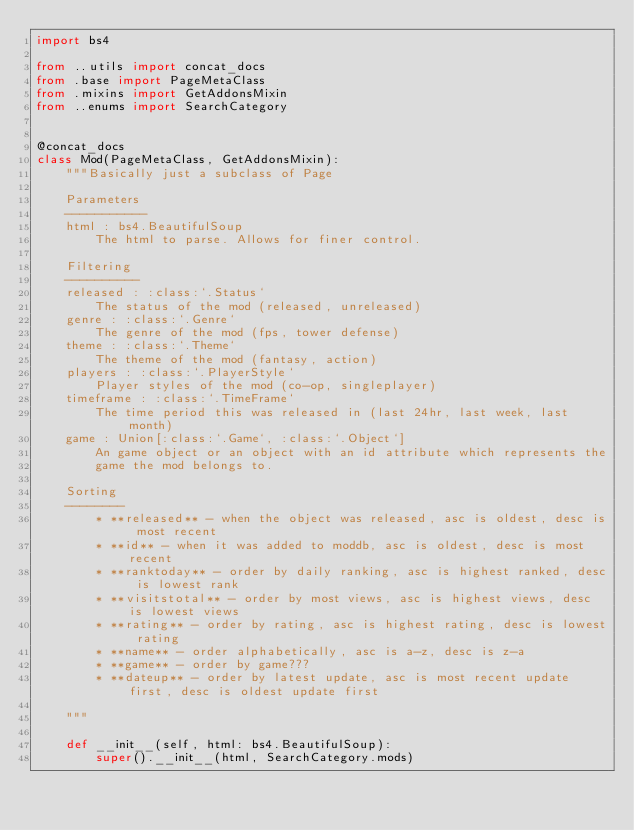<code> <loc_0><loc_0><loc_500><loc_500><_Python_>import bs4

from ..utils import concat_docs
from .base import PageMetaClass
from .mixins import GetAddonsMixin
from ..enums import SearchCategory


@concat_docs
class Mod(PageMetaClass, GetAddonsMixin):
    """Basically just a subclass of Page

    Parameters
    -----------
    html : bs4.BeautifulSoup
        The html to parse. Allows for finer control.

    Filtering
    ----------
    released : :class:`.Status`
        The status of the mod (released, unreleased)
    genre : :class:`.Genre`
        The genre of the mod (fps, tower defense)
    theme : :class:`.Theme`
        The theme of the mod (fantasy, action)
    players : :class:`.PlayerStyle`
        Player styles of the mod (co-op, singleplayer)
    timeframe : :class:`.TimeFrame`
        The time period this was released in (last 24hr, last week, last month)
    game : Union[:class:`.Game`, :class:`.Object`]
        An game object or an object with an id attribute which represents the
        game the mod belongs to.

    Sorting
    --------
        * **released** - when the object was released, asc is oldest, desc is most recent
        * **id** - when it was added to moddb, asc is oldest, desc is most recent
        * **ranktoday** - order by daily ranking, asc is highest ranked, desc is lowest rank
        * **visitstotal** - order by most views, asc is highest views, desc is lowest views
        * **rating** - order by rating, asc is highest rating, desc is lowest rating
        * **name** - order alphabetically, asc is a-z, desc is z-a
        * **game** - order by game???
        * **dateup** - order by latest update, asc is most recent update first, desc is oldest update first

    """

    def __init__(self, html: bs4.BeautifulSoup):
        super().__init__(html, SearchCategory.mods)
</code> 